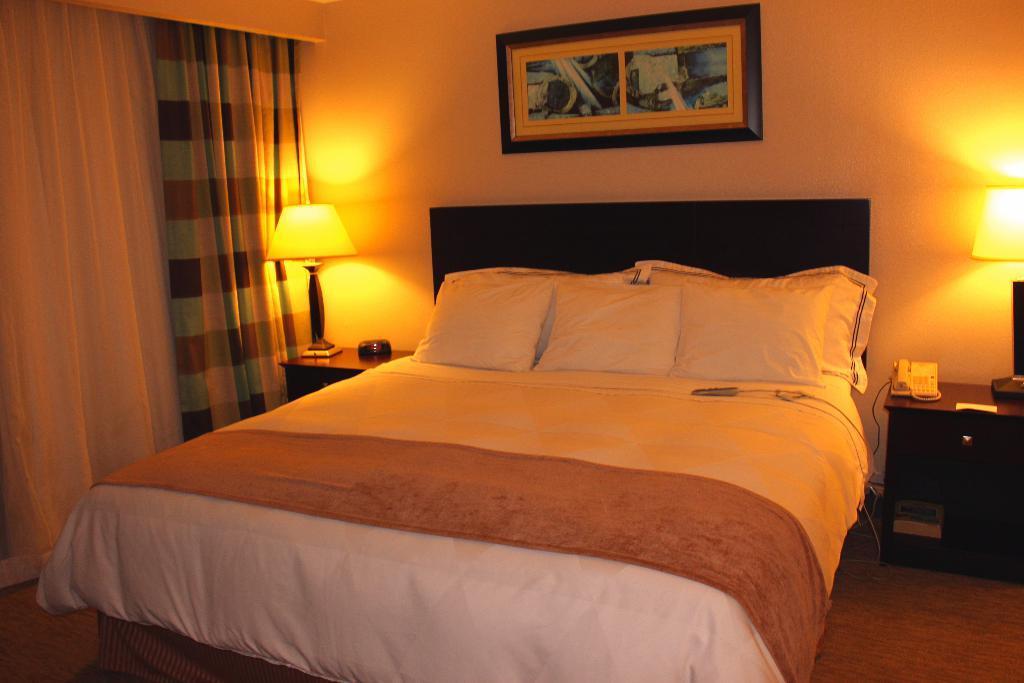Could you give a brief overview of what you see in this image? This is an inside picture of a room, we can see a bed, on the bed we can see the pillows, there are tables, on the tables we can see lamps, land phone and some other objects, also we can see the curtains and a photo frame on the wall. 